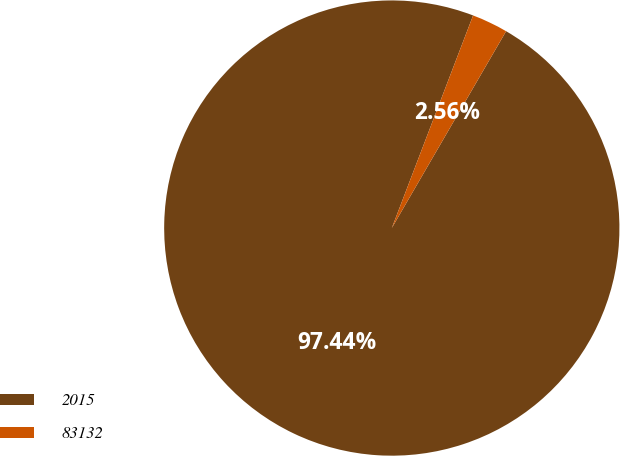Convert chart. <chart><loc_0><loc_0><loc_500><loc_500><pie_chart><fcel>2015<fcel>83132<nl><fcel>97.44%<fcel>2.56%<nl></chart> 